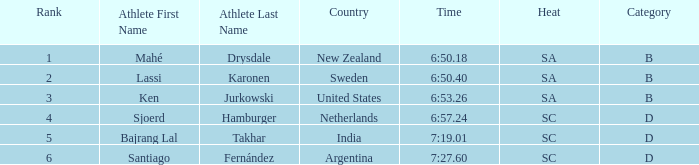What is the highest rank for the team that raced a time of 6:50.40? 2.0. 